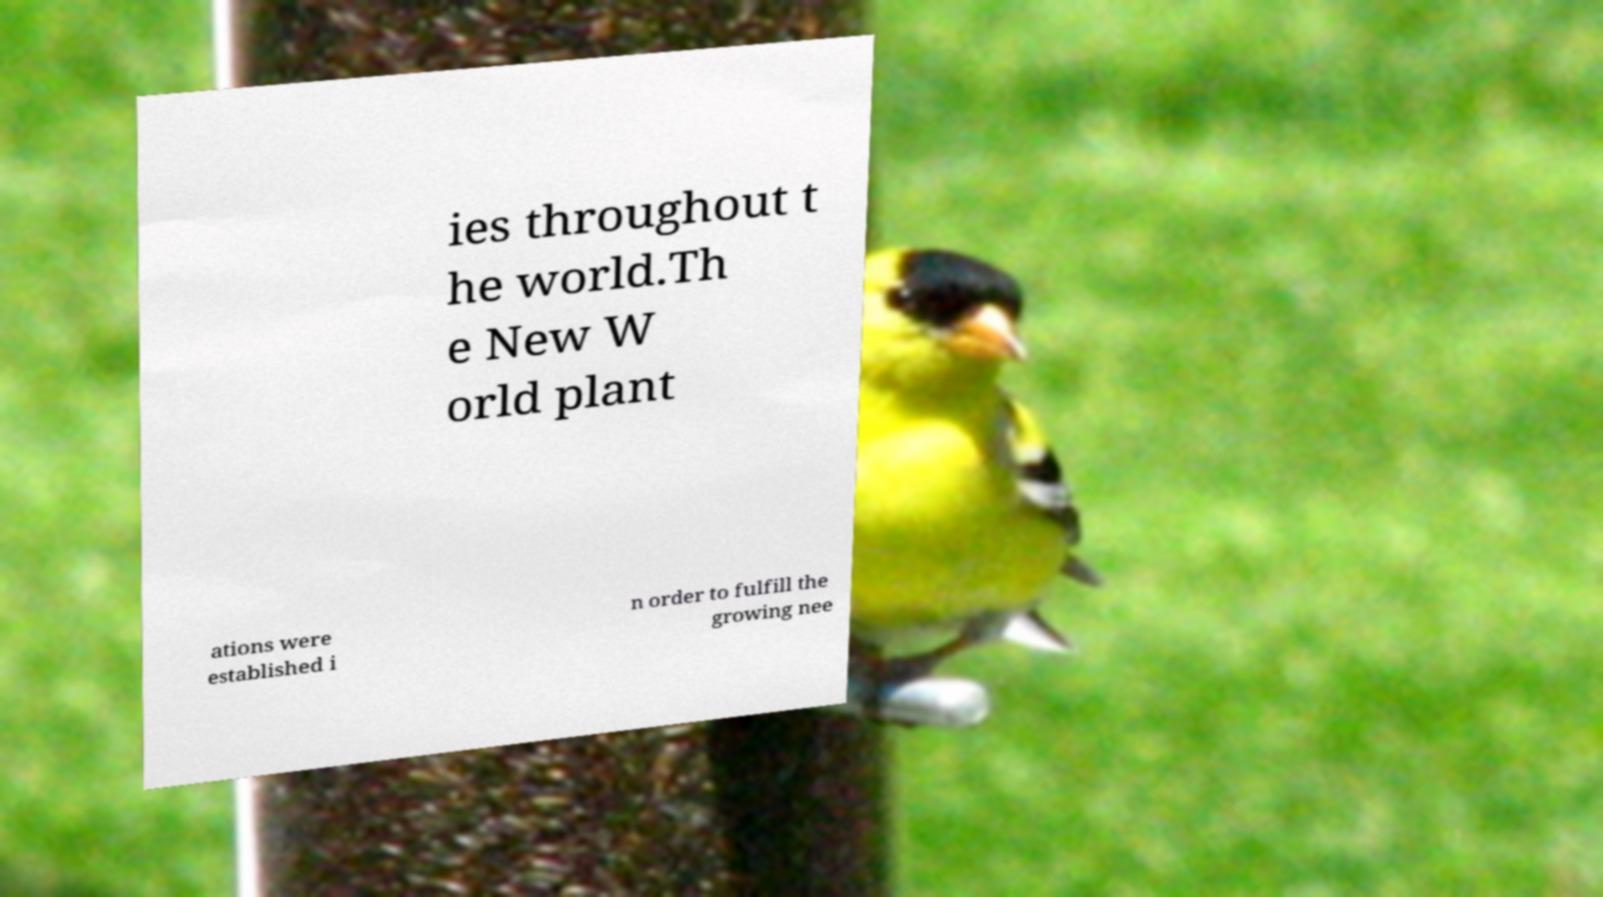Please identify and transcribe the text found in this image. ies throughout t he world.Th e New W orld plant ations were established i n order to fulfill the growing nee 